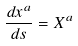<formula> <loc_0><loc_0><loc_500><loc_500>\frac { d x ^ { a } } { d s } = X ^ { a }</formula> 